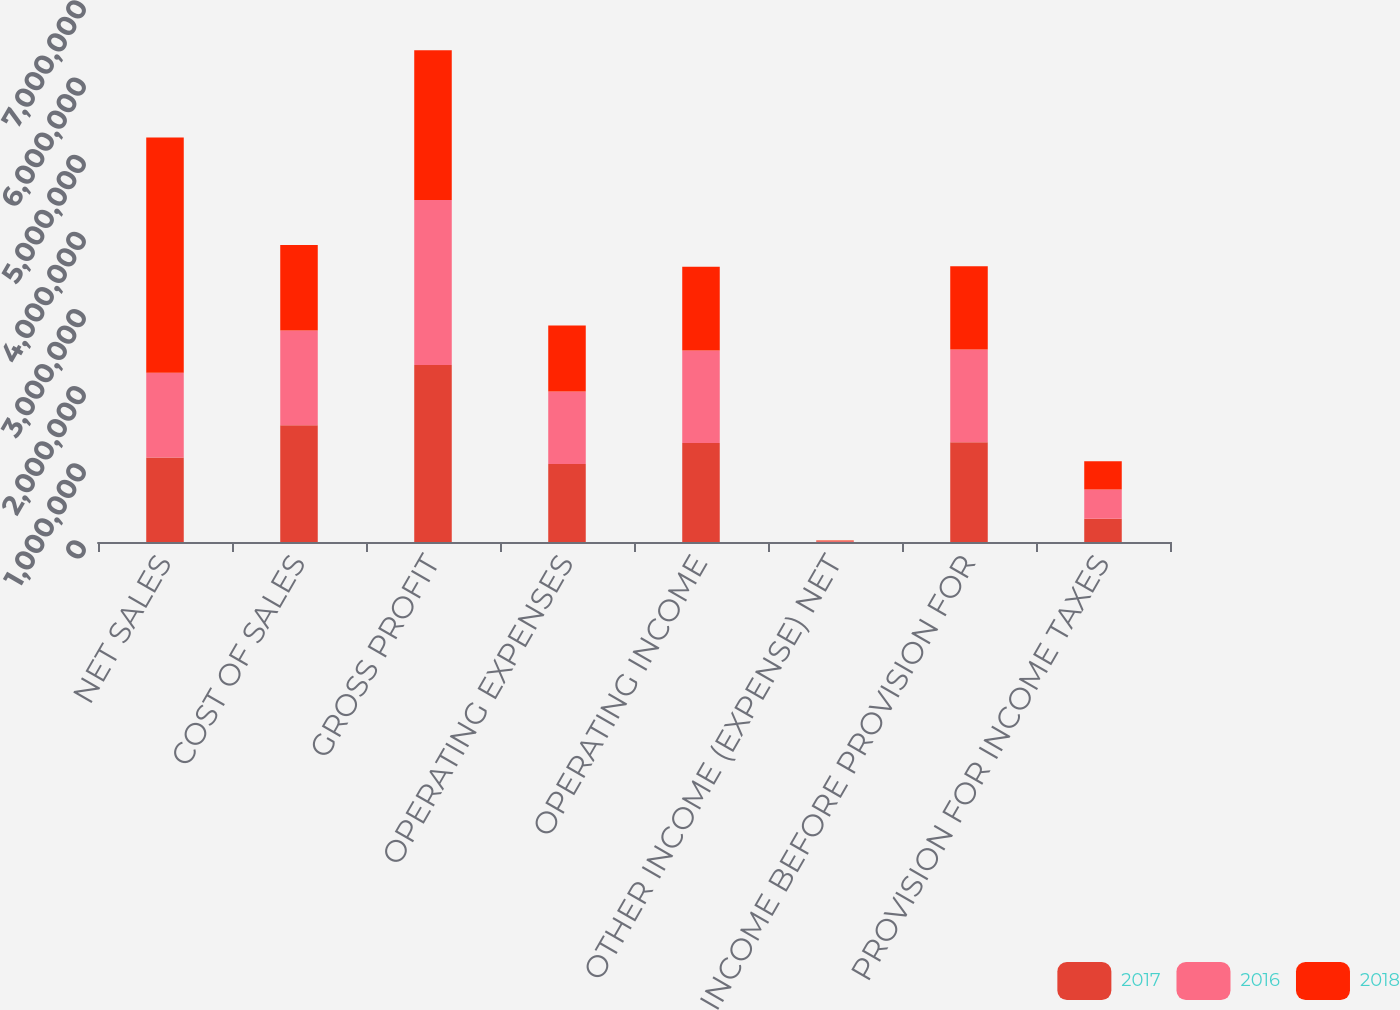Convert chart to OTSL. <chart><loc_0><loc_0><loc_500><loc_500><stacked_bar_chart><ecel><fcel>NET SALES<fcel>COST OF SALES<fcel>GROSS PROFIT<fcel>OPERATING EXPENSES<fcel>OPERATING INCOME<fcel>OTHER INCOME (EXPENSE) NET<fcel>INCOME BEFORE PROVISION FOR<fcel>PROVISION FOR INCOME TAXES<nl><fcel>2017<fcel>1.09637e+06<fcel>1.51181e+06<fcel>2.29538e+06<fcel>1.01176e+06<fcel>1.28362e+06<fcel>9653<fcel>1.29327e+06<fcel>300268<nl><fcel>2016<fcel>1.09637e+06<fcel>1.23136e+06<fcel>2.13769e+06<fcel>938903<fcel>1.19879e+06<fcel>2836<fcel>1.20162e+06<fcel>380945<nl><fcel>2018<fcel>3.04939e+06<fcel>1.10739e+06<fcel>1.942e+06<fcel>856662<fcel>1.08534e+06<fcel>5653<fcel>1.07968e+06<fcel>367000<nl></chart> 